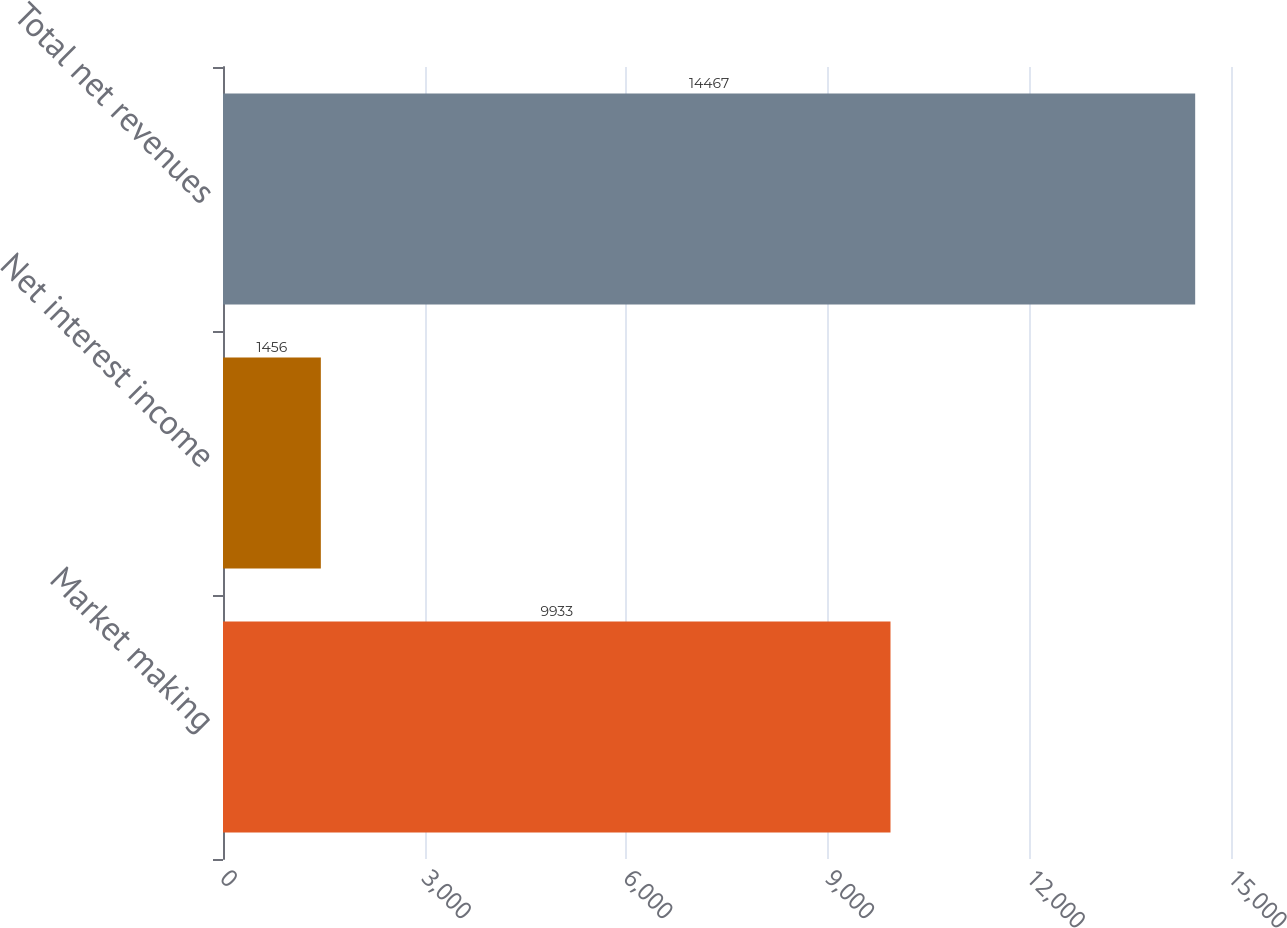Convert chart to OTSL. <chart><loc_0><loc_0><loc_500><loc_500><bar_chart><fcel>Market making<fcel>Net interest income<fcel>Total net revenues<nl><fcel>9933<fcel>1456<fcel>14467<nl></chart> 